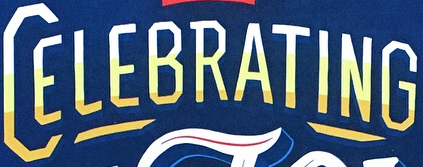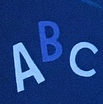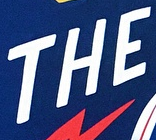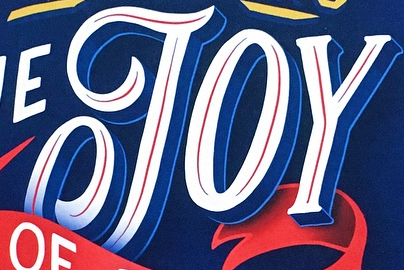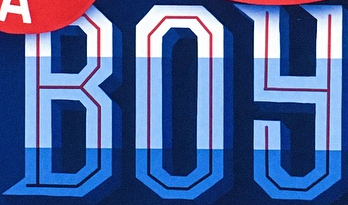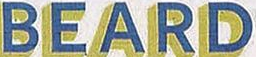Identify the words shown in these images in order, separated by a semicolon. CELEBRATING; ABC; THE; JOY; BOY; BEARD 